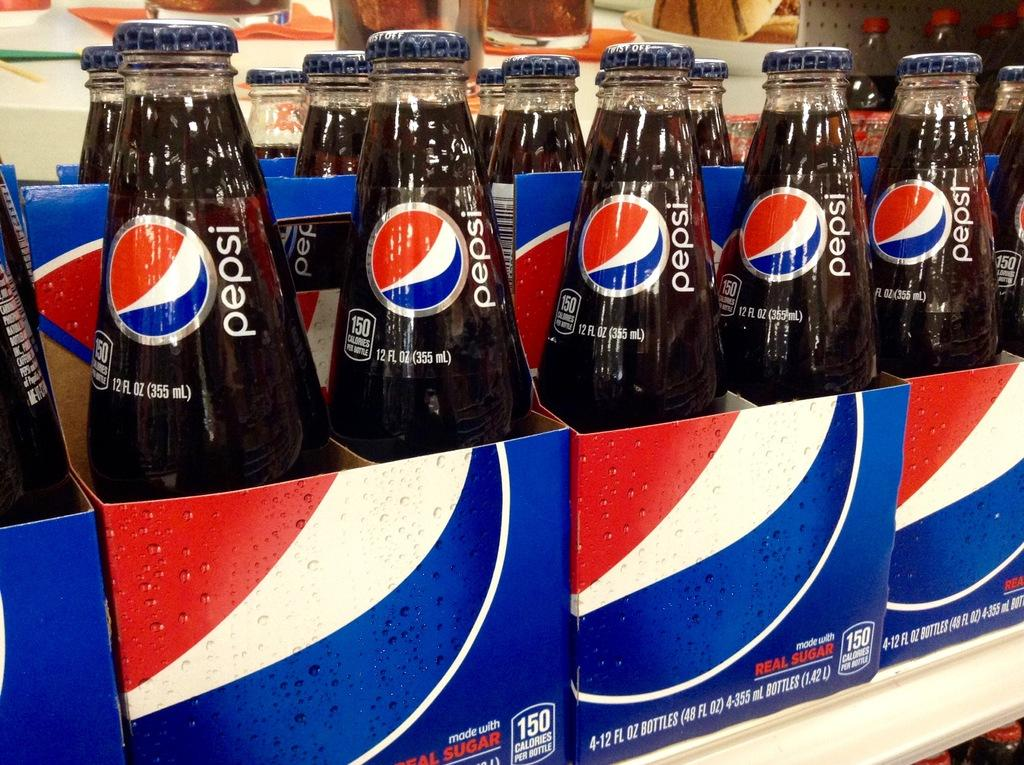<image>
Render a clear and concise summary of the photo. Bottles labeled "Pepsi" sit in cardboard carrying cartons. 